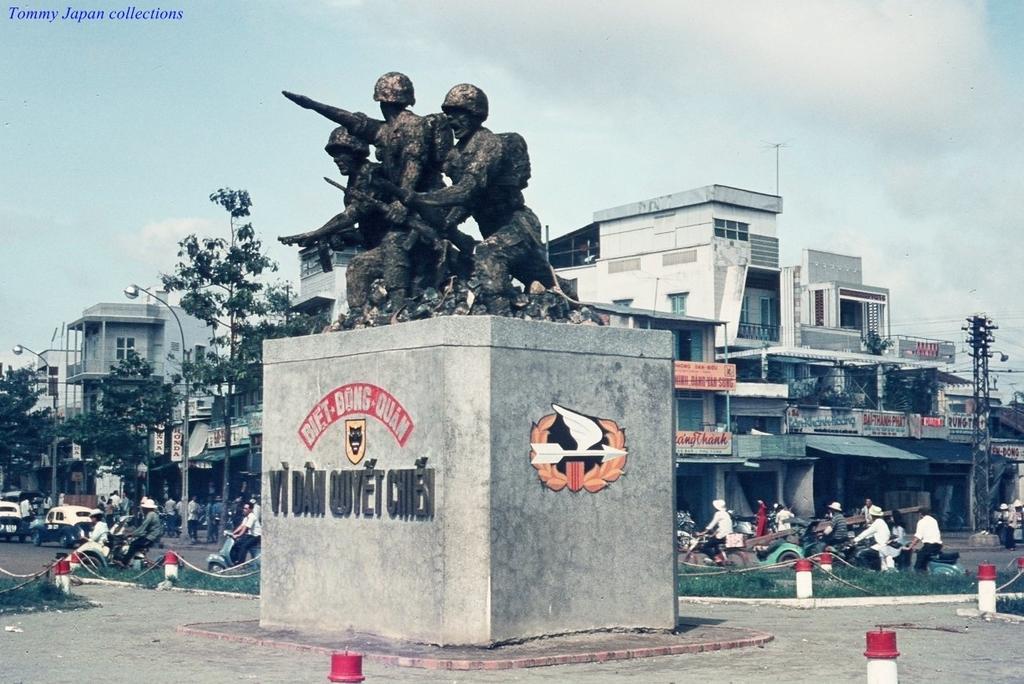Describe this image in one or two sentences. In this image, we can see a statue on the pillar. On the pillar we can see text and logos. At the bottom of the image, we can see poles. In the background, we can see poles, ropes, plants, people, buildings, boards, street lights, banners, trees, few objects and the sky. Few people riding vehicles on the road. In the top left corner, there is a watermark in the image. 